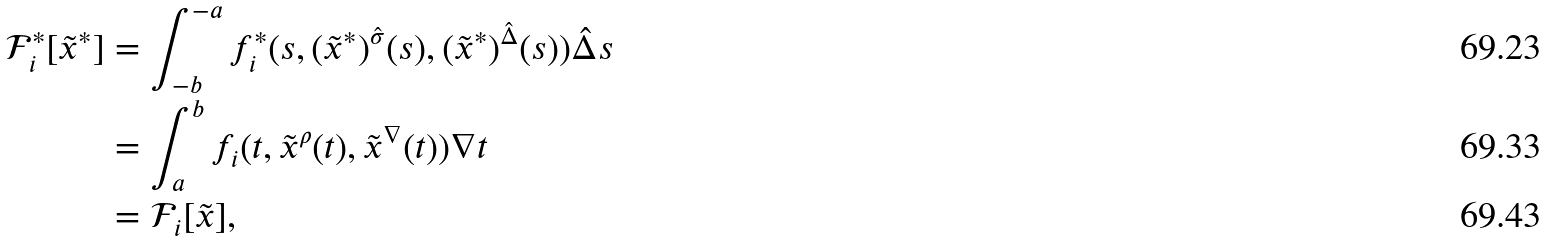Convert formula to latex. <formula><loc_0><loc_0><loc_500><loc_500>\mathcal { F } _ { i } ^ { * } [ \tilde { x } ^ { * } ] & = \int _ { - b } ^ { - a } f _ { i } ^ { * } ( s , ( \tilde { x } ^ { * } ) ^ { \hat { \sigma } } ( s ) , ( \tilde { x } ^ { * } ) ^ { \hat { \Delta } } ( s ) ) \hat { \Delta } s \\ & = \int _ { a } ^ { b } f _ { i } ( t , \tilde { x } ^ { \rho } ( t ) , \tilde { x } ^ { \nabla } ( t ) ) \nabla t \\ & = \mathcal { F } _ { i } [ \tilde { x } ] ,</formula> 